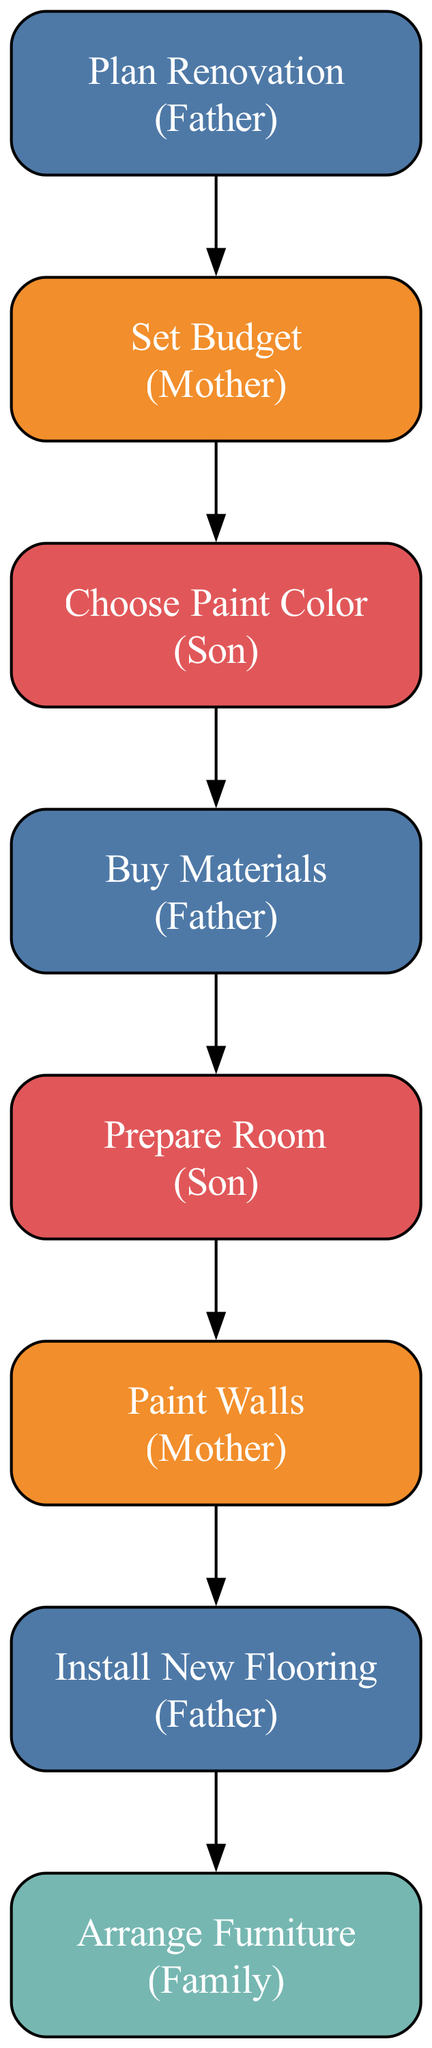What task does the Father undertake first? According to the diagram, the Father is responsible for the first task, which is "Plan Renovation." This is the initial step in the workflow and clearly outlines his role.
Answer: Plan Renovation Who is responsible for setting the budget? The diagram indicates that the Mother is in charge of the "Set Budget" task, which follows the planning step. This makes it clear who takes on this responsibility.
Answer: Mother How many total tasks are listed in the diagram? The diagram includes eight distinct tasks, as represented by the nodes in the directed graph. Each task is a step towards completing the renovation project.
Answer: Eight Which task comes after "Choose Paint Color"? Following the "Choose Paint Color" task in the sequence shown in the diagram, the next task is "Buy Materials." This is determined by looking at the directed edges from one task to the next.
Answer: Buy Materials What color represents the Son's responsibilities? The diagram uses a specific color code, and the Son's responsibilities are shown in red, represented by the hex color #E15759. This can be confirmed by examining the node colors associated with his tasks.
Answer: Red What task is performed after the painting is completed? According to the progression of tasks in the diagram, the task that comes after "Paint Walls" is "Install New Flooring." This is determined by the directed edges flowing from one task to the next.
Answer: Install New Flooring How many edges connect the tasks in the diagram? The diagram features seven directed edges, each representing a connection from one task to the next in the workflow. This can be verified by counting the relationships established in the edges section.
Answer: Seven Who is responsible for arranging the furniture? The diagram specifies that the final task, "Arrange Furniture," is a collective responsibility of the Family. This indicates a collaborative effort after all previous tasks have been completed.
Answer: Family What is the last task in the renovation sequence? The sequence in the diagram culminates with "Arrange Furniture," indicating that this is the final step once all other tasks have been completed. This information is derived from tracing the edges from the previous tasks.
Answer: Arrange Furniture 